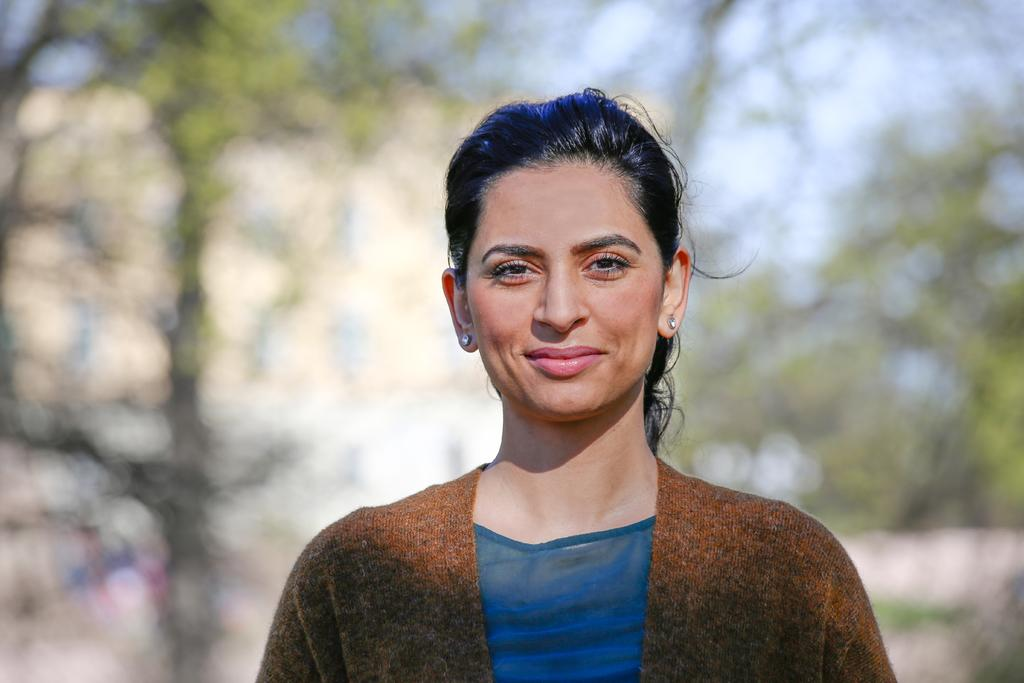Who is present in the image? There is a woman in the image. What is the woman's facial expression? The woman is smiling. Can you describe the background of the image? The background of the image is blurred. What type of horn can be seen on the woman's head in the image? There is no horn present on the woman's head in the image. 